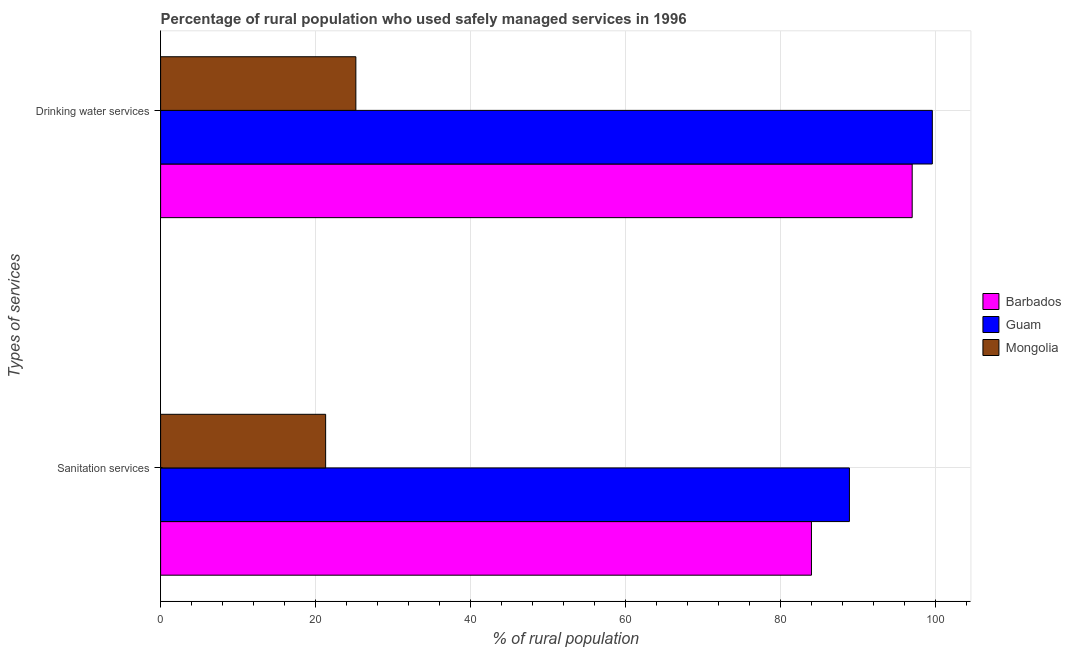How many different coloured bars are there?
Offer a very short reply. 3. How many groups of bars are there?
Offer a terse response. 2. How many bars are there on the 1st tick from the top?
Keep it short and to the point. 3. What is the label of the 1st group of bars from the top?
Your answer should be compact. Drinking water services. What is the percentage of rural population who used sanitation services in Guam?
Offer a terse response. 88.9. Across all countries, what is the maximum percentage of rural population who used sanitation services?
Offer a very short reply. 88.9. Across all countries, what is the minimum percentage of rural population who used drinking water services?
Your answer should be compact. 25.2. In which country was the percentage of rural population who used sanitation services maximum?
Your answer should be very brief. Guam. In which country was the percentage of rural population who used drinking water services minimum?
Provide a short and direct response. Mongolia. What is the total percentage of rural population who used drinking water services in the graph?
Offer a very short reply. 221.8. What is the difference between the percentage of rural population who used sanitation services in Guam and that in Barbados?
Your answer should be very brief. 4.9. What is the difference between the percentage of rural population who used sanitation services in Guam and the percentage of rural population who used drinking water services in Barbados?
Provide a succinct answer. -8.1. What is the average percentage of rural population who used sanitation services per country?
Give a very brief answer. 64.73. What is the difference between the percentage of rural population who used drinking water services and percentage of rural population who used sanitation services in Guam?
Provide a succinct answer. 10.7. In how many countries, is the percentage of rural population who used sanitation services greater than 100 %?
Your answer should be compact. 0. What is the ratio of the percentage of rural population who used drinking water services in Mongolia to that in Barbados?
Provide a succinct answer. 0.26. What does the 2nd bar from the top in Drinking water services represents?
Keep it short and to the point. Guam. What does the 3rd bar from the bottom in Drinking water services represents?
Provide a short and direct response. Mongolia. What is the difference between two consecutive major ticks on the X-axis?
Your answer should be compact. 20. Does the graph contain any zero values?
Provide a succinct answer. No. Does the graph contain grids?
Provide a succinct answer. Yes. What is the title of the graph?
Give a very brief answer. Percentage of rural population who used safely managed services in 1996. Does "Georgia" appear as one of the legend labels in the graph?
Your response must be concise. No. What is the label or title of the X-axis?
Make the answer very short. % of rural population. What is the label or title of the Y-axis?
Keep it short and to the point. Types of services. What is the % of rural population in Guam in Sanitation services?
Your answer should be compact. 88.9. What is the % of rural population of Mongolia in Sanitation services?
Your response must be concise. 21.3. What is the % of rural population in Barbados in Drinking water services?
Give a very brief answer. 97. What is the % of rural population in Guam in Drinking water services?
Your answer should be compact. 99.6. What is the % of rural population in Mongolia in Drinking water services?
Your answer should be very brief. 25.2. Across all Types of services, what is the maximum % of rural population of Barbados?
Your answer should be very brief. 97. Across all Types of services, what is the maximum % of rural population in Guam?
Keep it short and to the point. 99.6. Across all Types of services, what is the maximum % of rural population in Mongolia?
Your answer should be compact. 25.2. Across all Types of services, what is the minimum % of rural population of Barbados?
Make the answer very short. 84. Across all Types of services, what is the minimum % of rural population of Guam?
Ensure brevity in your answer.  88.9. Across all Types of services, what is the minimum % of rural population in Mongolia?
Provide a succinct answer. 21.3. What is the total % of rural population of Barbados in the graph?
Provide a short and direct response. 181. What is the total % of rural population of Guam in the graph?
Ensure brevity in your answer.  188.5. What is the total % of rural population in Mongolia in the graph?
Provide a succinct answer. 46.5. What is the difference between the % of rural population of Barbados in Sanitation services and that in Drinking water services?
Offer a very short reply. -13. What is the difference between the % of rural population of Guam in Sanitation services and that in Drinking water services?
Your answer should be compact. -10.7. What is the difference between the % of rural population of Barbados in Sanitation services and the % of rural population of Guam in Drinking water services?
Offer a terse response. -15.6. What is the difference between the % of rural population of Barbados in Sanitation services and the % of rural population of Mongolia in Drinking water services?
Give a very brief answer. 58.8. What is the difference between the % of rural population of Guam in Sanitation services and the % of rural population of Mongolia in Drinking water services?
Give a very brief answer. 63.7. What is the average % of rural population of Barbados per Types of services?
Offer a very short reply. 90.5. What is the average % of rural population of Guam per Types of services?
Your answer should be very brief. 94.25. What is the average % of rural population of Mongolia per Types of services?
Provide a succinct answer. 23.25. What is the difference between the % of rural population in Barbados and % of rural population in Guam in Sanitation services?
Provide a short and direct response. -4.9. What is the difference between the % of rural population of Barbados and % of rural population of Mongolia in Sanitation services?
Keep it short and to the point. 62.7. What is the difference between the % of rural population in Guam and % of rural population in Mongolia in Sanitation services?
Offer a terse response. 67.6. What is the difference between the % of rural population in Barbados and % of rural population in Guam in Drinking water services?
Your answer should be very brief. -2.6. What is the difference between the % of rural population in Barbados and % of rural population in Mongolia in Drinking water services?
Your answer should be very brief. 71.8. What is the difference between the % of rural population in Guam and % of rural population in Mongolia in Drinking water services?
Your response must be concise. 74.4. What is the ratio of the % of rural population in Barbados in Sanitation services to that in Drinking water services?
Your answer should be compact. 0.87. What is the ratio of the % of rural population in Guam in Sanitation services to that in Drinking water services?
Keep it short and to the point. 0.89. What is the ratio of the % of rural population in Mongolia in Sanitation services to that in Drinking water services?
Keep it short and to the point. 0.85. What is the difference between the highest and the second highest % of rural population of Barbados?
Provide a short and direct response. 13. What is the difference between the highest and the second highest % of rural population of Guam?
Provide a succinct answer. 10.7. What is the difference between the highest and the lowest % of rural population of Guam?
Offer a very short reply. 10.7. 